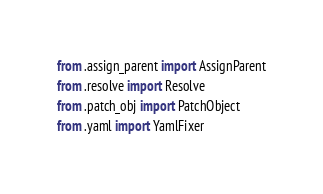Convert code to text. <code><loc_0><loc_0><loc_500><loc_500><_Python_>from .assign_parent import AssignParent
from .resolve import Resolve
from .patch_obj import PatchObject
from .yaml import YamlFixer
</code> 